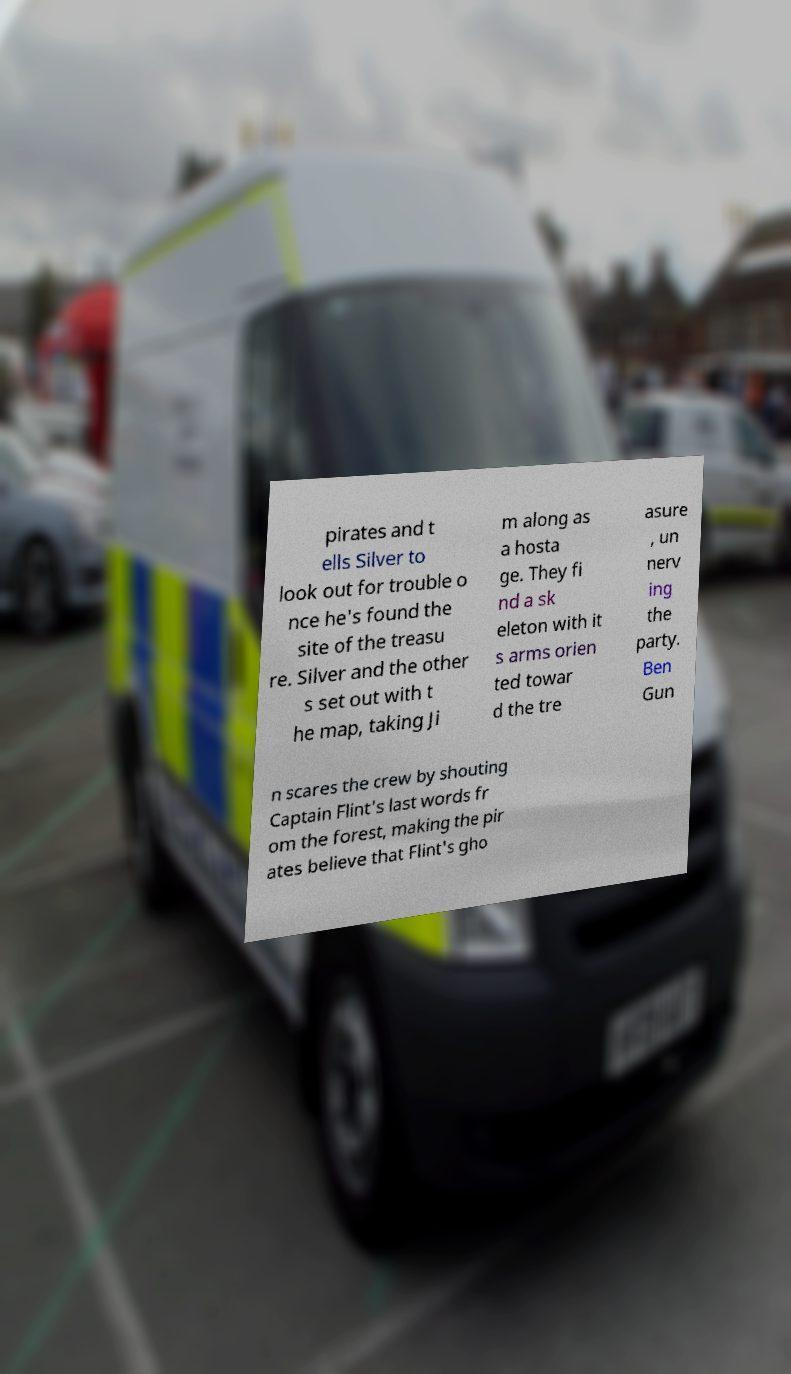Please read and relay the text visible in this image. What does it say? pirates and t ells Silver to look out for trouble o nce he's found the site of the treasu re. Silver and the other s set out with t he map, taking Ji m along as a hosta ge. They fi nd a sk eleton with it s arms orien ted towar d the tre asure , un nerv ing the party. Ben Gun n scares the crew by shouting Captain Flint's last words fr om the forest, making the pir ates believe that Flint's gho 